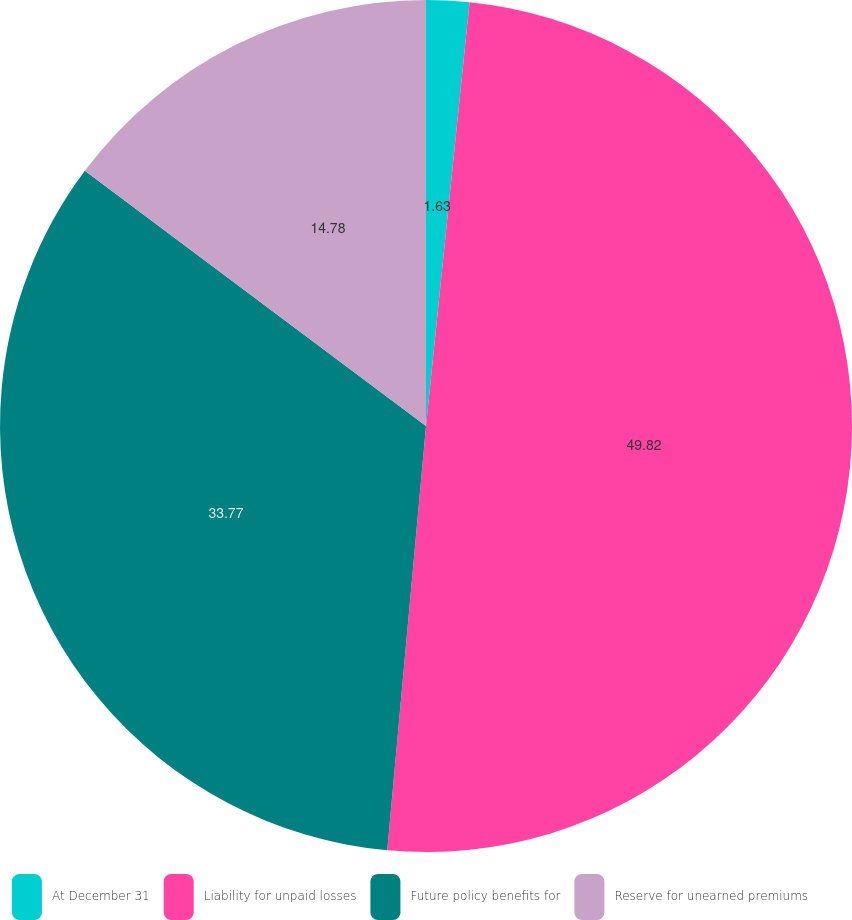Convert chart. <chart><loc_0><loc_0><loc_500><loc_500><pie_chart><fcel>At December 31<fcel>Liability for unpaid losses<fcel>Future policy benefits for<fcel>Reserve for unearned premiums<nl><fcel>1.63%<fcel>49.82%<fcel>33.77%<fcel>14.78%<nl></chart> 